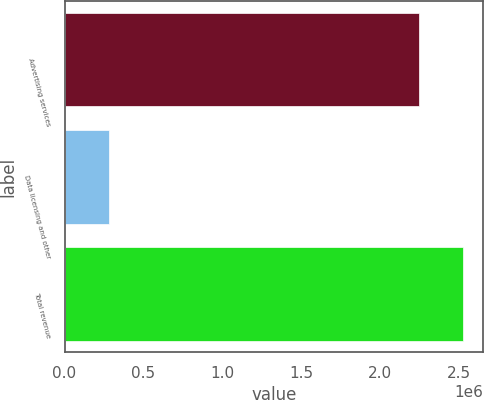Convert chart. <chart><loc_0><loc_0><loc_500><loc_500><bar_chart><fcel>Advertising services<fcel>Data licensing and other<fcel>Total revenue<nl><fcel>2.24805e+06<fcel>281567<fcel>2.52962e+06<nl></chart> 